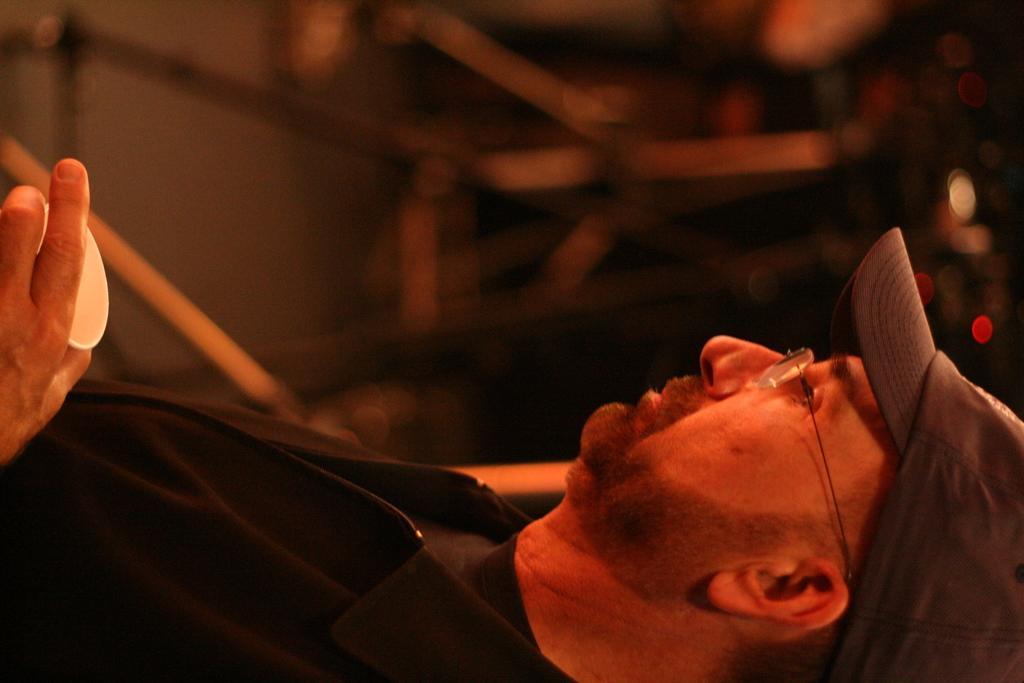Please provide a concise description of this image. In the picture I can see a person wearing black color jacket, spectacles and cap is holding a cup in his hand. The background of the image is dark and slightly blurred. 